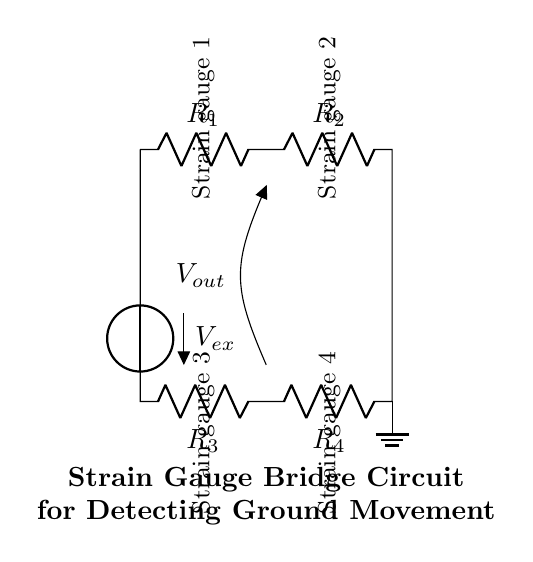What type of circuit is shown in the diagram? The diagram depicts a bridge circuit, specifically a strain gauge bridge used for measuring small changes in resistance due to strain or movement.
Answer: Bridge circuit How many resistors are in the circuit? There are four resistors labeled as R1, R2, R3, and R4 present in the bridge circuit.
Answer: Four What do the labels "strain gauge 1" and "strain gauge 2" indicate? The labels refer to the components that are used to measure strain at different points, indicating where strain gauges are installed within the bridge circuit.
Answer: Strain gauges What is the purpose of the voltage source in this circuit? The voltage source provides the required excitation voltage for the strain gauge bridge to operate and measure variations in resistance due to strain.
Answer: To provide excitation voltage How does the output voltage relate to ground movement? The output voltage (Vout) changes in response to variations in the resistance of the strain gauges caused by ground movement, allowing for detection of these changes.
Answer: It indicates resistance changes due to ground movement What is the function of the ground symbol in this circuit? The ground symbol denotes a reference point in the circuit, ensuring that voltage measurements are consistent and referencing to a common ground potential.
Answer: Reference point What happens if one strain gauge fails in the circuit? If one strain gauge fails, the balance of the bridge is disrupted, causing an improper output voltage, which may lead to inaccurate readings or measurements.
Answer: Disrupted balance 